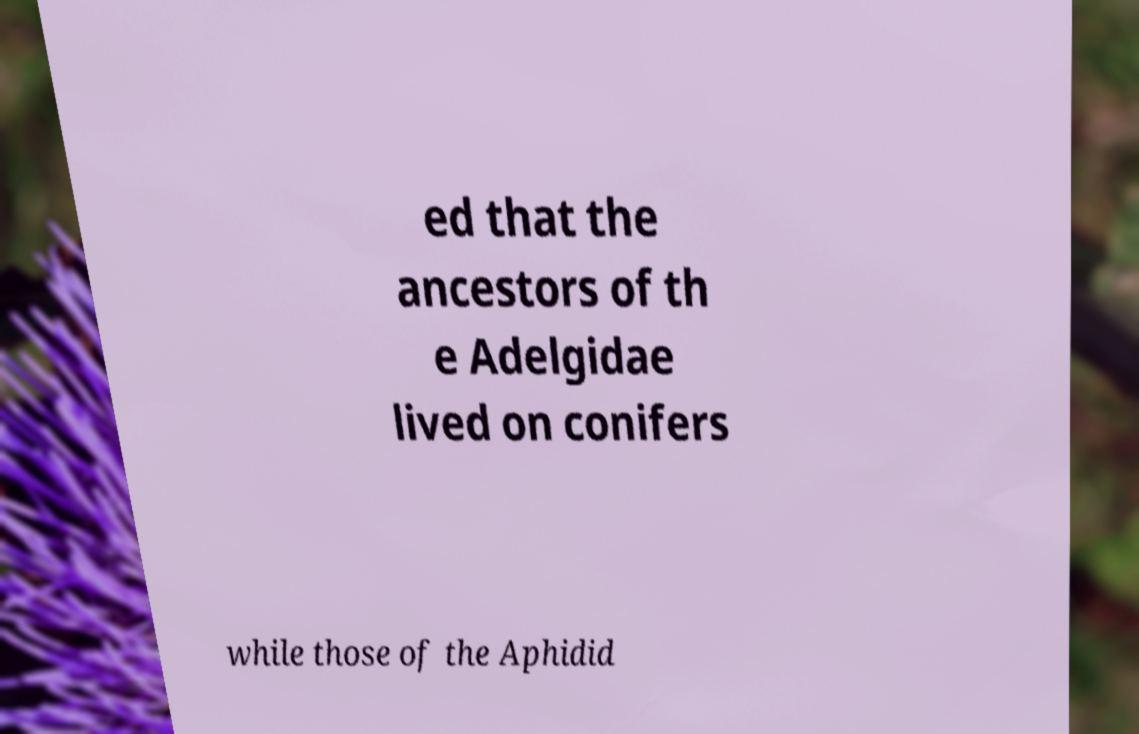Please read and relay the text visible in this image. What does it say? ed that the ancestors of th e Adelgidae lived on conifers while those of the Aphidid 